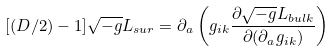Convert formula to latex. <formula><loc_0><loc_0><loc_500><loc_500>[ ( D / 2 ) - 1 ] \sqrt { - g } L _ { s u r } = \partial _ { a } \left ( g _ { i k } \frac { \partial \sqrt { - g } L _ { b u l k } } { \partial ( \partial _ { a } g _ { i k } ) } \right )</formula> 